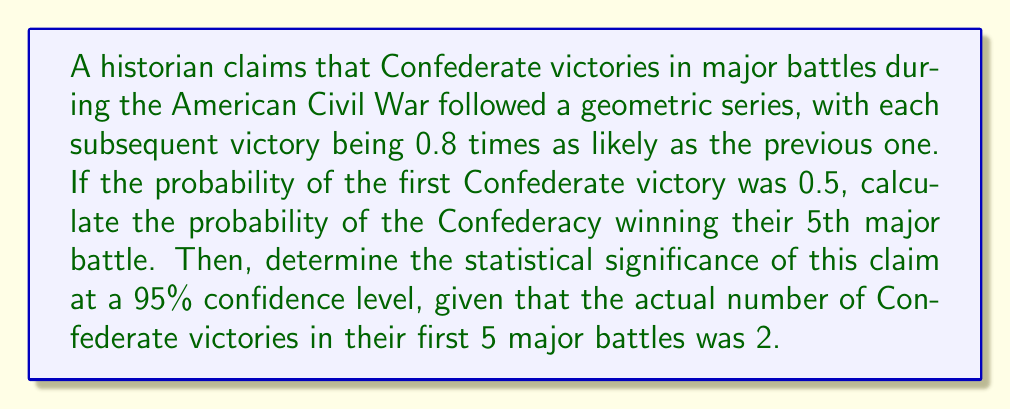Solve this math problem. Let's approach this problem step-by-step:

1) First, we need to calculate the probability of the Confederacy winning their 5th major battle. Given that this follows a geometric series with a common ratio of 0.8, we can use the formula:

   $$a_n = a_1 \cdot r^{n-1}$$

   Where $a_1 = 0.5$ (probability of first victory), $r = 0.8$ (common ratio), and $n = 5$ (5th battle).

2) Plugging in these values:

   $$a_5 = 0.5 \cdot 0.8^{5-1} = 0.5 \cdot 0.8^4 = 0.5 \cdot 0.4096 = 0.2048$$

3) Now, to determine the statistical significance, we need to compare the expected number of victories with the actual number. The expected number is the sum of probabilities for the first 5 battles:

   $$E = 0.5 + 0.5(0.8) + 0.5(0.8^2) + 0.5(0.8^3) + 0.5(0.8^4) = 1.8600$$

4) The actual number of victories is 2. We can use a chi-square test to determine significance:

   $$\chi^2 = \frac{(O - E)^2}{E} = \frac{(2 - 1.8600)^2}{1.8600} = 0.0105$$

5) For a 95% confidence level with 1 degree of freedom, the critical value is 3.841.

6) Since our calculated $\chi^2$ (0.0105) is less than the critical value (3.841), we fail to reject the null hypothesis.
Answer: Probability of 5th victory: 0.2048. Claim not statistically significant at 95% confidence level. 